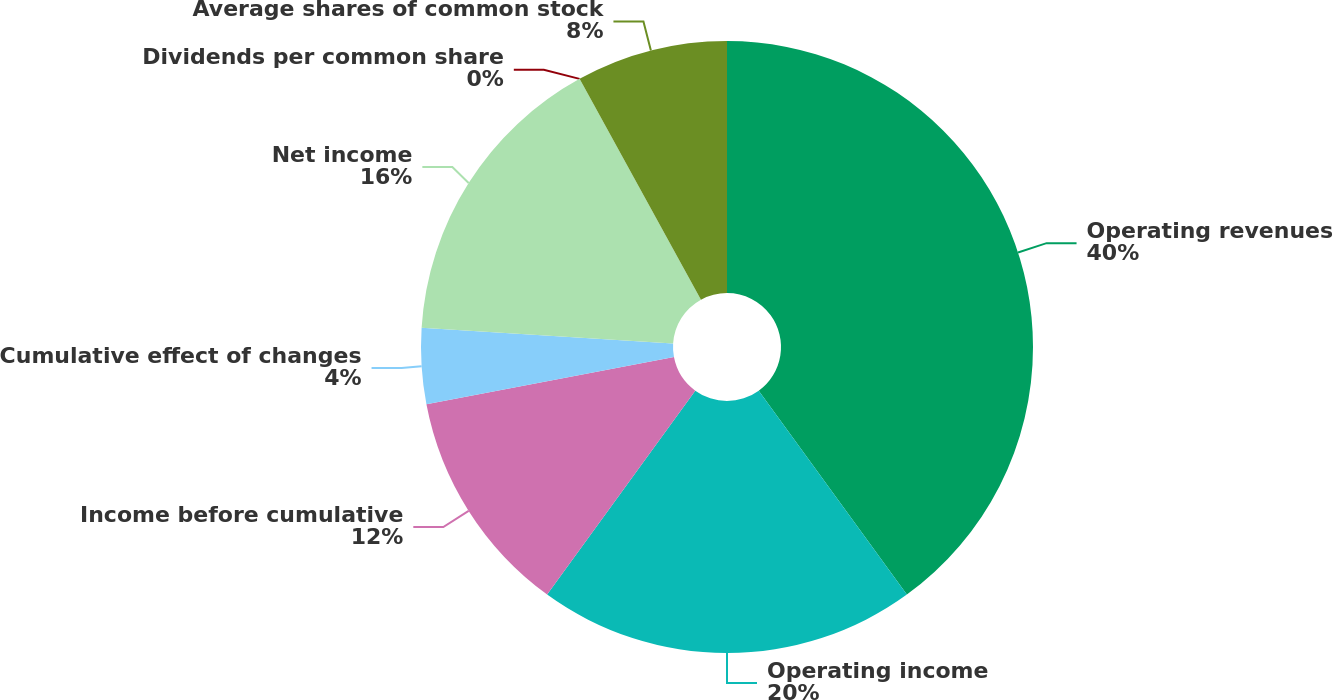<chart> <loc_0><loc_0><loc_500><loc_500><pie_chart><fcel>Operating revenues<fcel>Operating income<fcel>Income before cumulative<fcel>Cumulative effect of changes<fcel>Net income<fcel>Dividends per common share<fcel>Average shares of common stock<nl><fcel>40.0%<fcel>20.0%<fcel>12.0%<fcel>4.0%<fcel>16.0%<fcel>0.0%<fcel>8.0%<nl></chart> 